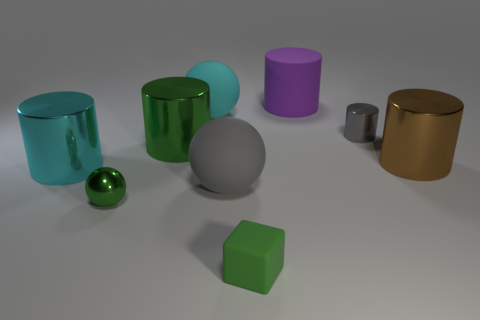There is a gray object that is the same shape as the big brown object; what is its size?
Provide a short and direct response. Small. Is the shape of the purple thing the same as the big object that is on the left side of the green sphere?
Your answer should be very brief. Yes. What is the size of the gray cylinder?
Give a very brief answer. Small. Are there fewer large shiny cylinders that are on the right side of the big gray matte object than green shiny things?
Give a very brief answer. Yes. What number of green spheres are the same size as the gray shiny cylinder?
Your answer should be compact. 1. There is another small object that is the same color as the tiny rubber thing; what is its shape?
Offer a terse response. Sphere. There is a rubber thing that is in front of the large gray thing; does it have the same color as the matte ball in front of the gray shiny thing?
Your response must be concise. No. What number of cyan metallic cylinders are behind the matte cylinder?
Provide a succinct answer. 0. The cylinder that is the same color as the tiny shiny sphere is what size?
Provide a short and direct response. Large. Are there any small gray objects that have the same shape as the large brown shiny thing?
Your answer should be compact. Yes. 